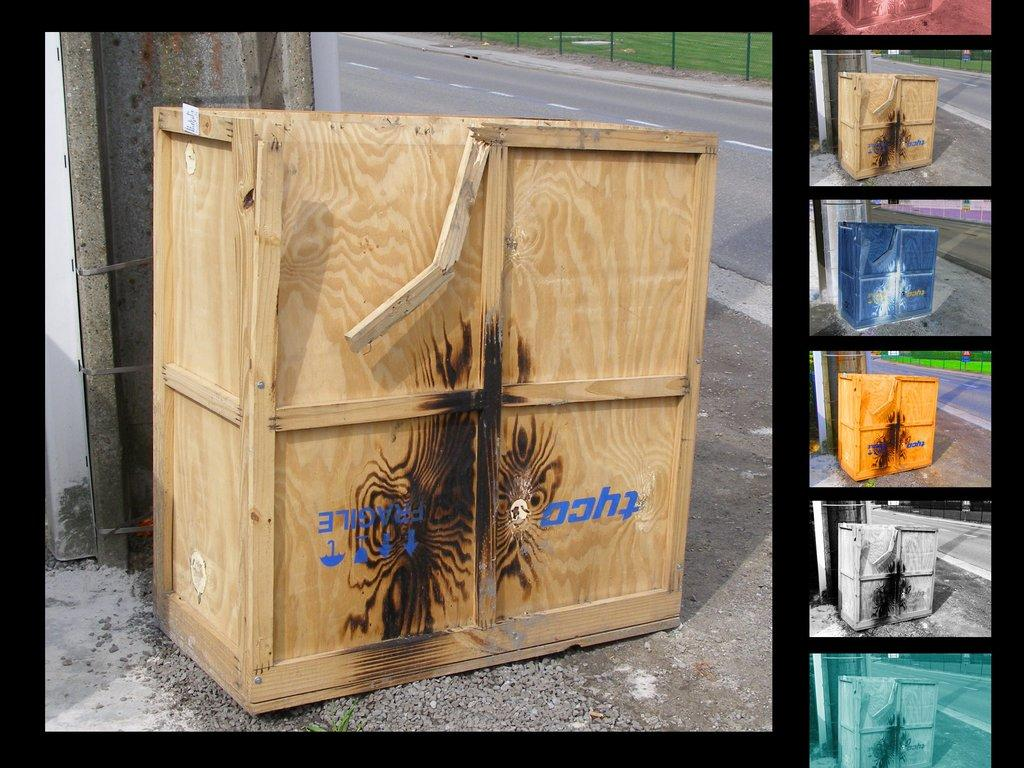What object is made of wood and present in the image? There is a wooden box in the image. What can be found on the wooden box? There is text written on the wooden box. What can be seen on the right side of the image? The right side of the image contains pictures in different colors. What color are the borders in the image? The borders in the image are black in color. What type of company is depicted in the image? There is no company depicted in the image; it features a wooden box with text and pictures in different colors. How does the plough contribute to the image? There is no plough present in the image. 